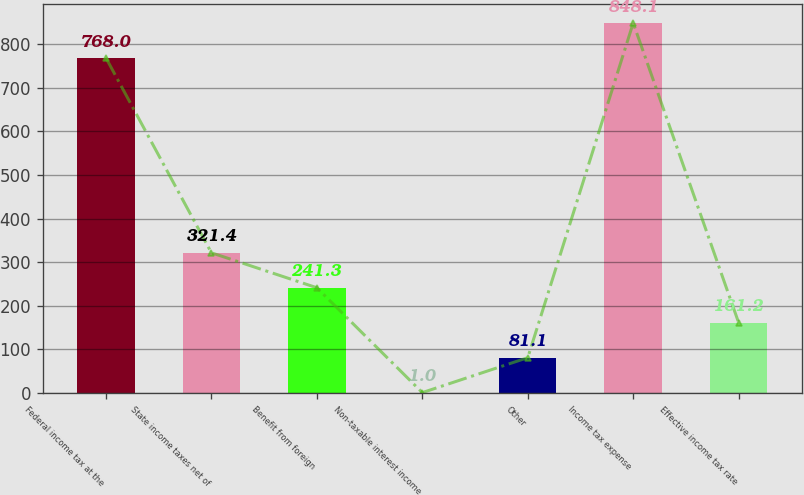Convert chart. <chart><loc_0><loc_0><loc_500><loc_500><bar_chart><fcel>Federal income tax at the<fcel>State income taxes net of<fcel>Benefit from foreign<fcel>Non-taxable interest income<fcel>Other<fcel>Income tax expense<fcel>Effective income tax rate<nl><fcel>768<fcel>321.4<fcel>241.3<fcel>1<fcel>81.1<fcel>848.1<fcel>161.2<nl></chart> 